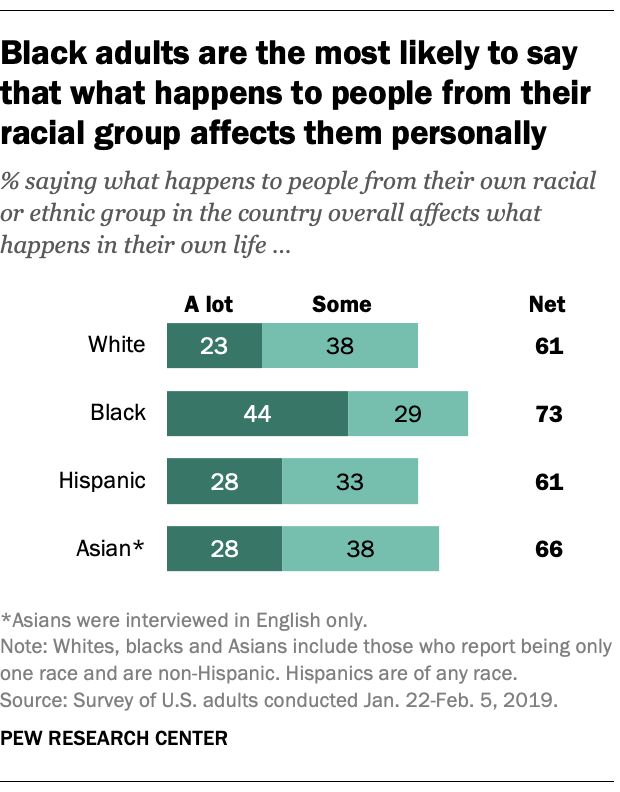Identify some key points in this picture. The mode of the light green bars is 38. The mode and the average of the net percentages of all the races are 65.25. 